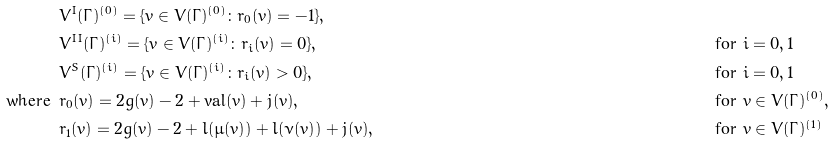<formula> <loc_0><loc_0><loc_500><loc_500>& V ^ { I } ( \Gamma ) ^ { ( 0 ) } = \{ v \in V ( \Gamma ) ^ { ( 0 ) } \colon r _ { 0 } ( v ) = - 1 \} , \\ & V ^ { I I } ( \Gamma ) ^ { ( i ) } = \{ v \in V ( \Gamma ) ^ { ( i ) } \colon r _ { i } ( v ) = 0 \} , & & \text {for } i = 0 , 1 \\ & V ^ { S } ( \Gamma ) ^ { ( i ) } = \{ v \in V ( \Gamma ) ^ { ( i ) } \colon r _ { i } ( v ) > 0 \} , & & \text {for } i = 0 , 1 \\ \text {where } \, & r _ { 0 } ( v ) = 2 g ( v ) - 2 + \text {val} ( v ) + j ( v ) , & & \text {for } v \in V ( \Gamma ) ^ { ( 0 ) } , \\ & r _ { 1 } ( v ) = 2 g ( v ) - 2 + l ( \mu ( v ) ) + l ( \nu ( v ) ) + j ( v ) , & & \text {for } v \in V ( \Gamma ) ^ { ( 1 ) }</formula> 